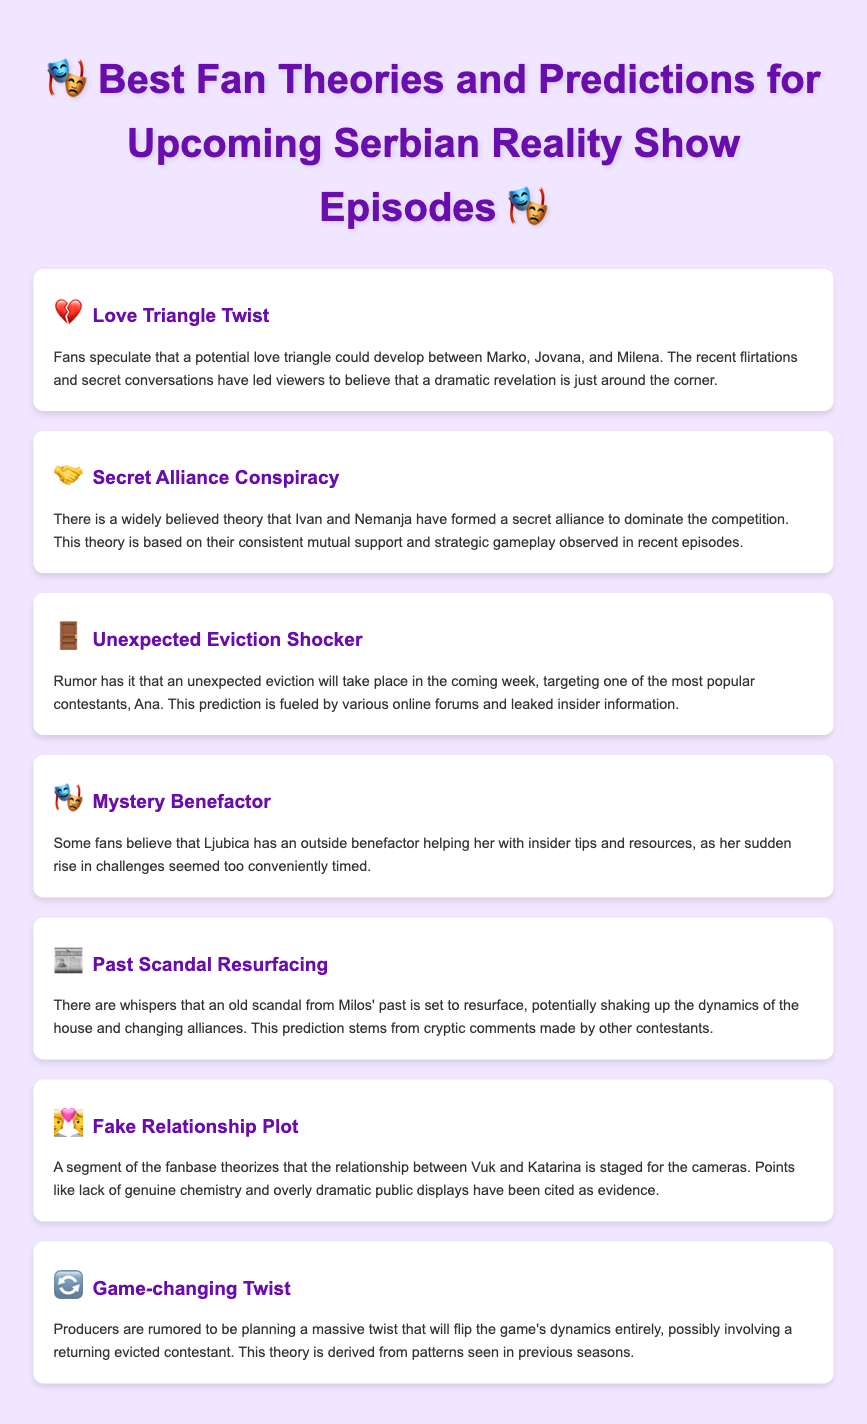What is the first fan theory listed? The first fan theory listed is the one about a love triangle involving Marko, Jovana, and Milena.
Answer: Love Triangle Twist Who are the contestants involved in the secret alliance theory? The contestants involved are Ivan and Nemanja, who are theorized to have formed a secret alliance.
Answer: Ivan and Nemanja What potential event is rumored to happen next week? The document suggests that an unexpected eviction is rumored to take place.
Answer: Unexpected eviction Which contestant is targeted for the rumored eviction? According to the prediction, Ana is the contestant targeted for eviction.
Answer: Ana What is the main speculation about Ljubica? Fans speculate that Ljubica has an outside benefactor helping her with insider tips.
Answer: Mystery Benefactor What type of plot is theorized about Vuk and Katarina? The theory suggests that Vuk and Katarina's relationship may be staged for the cameras.
Answer: Fake Relationship Plot What is the nature of the upcoming twist anticipated by fans? Fans anticipate a game-changing twist that could involve a returning evicted contestant.
Answer: Game-changing Twist What do fans think is going to resurface from Milos' past? Fans believe that an old scandal involving Milos is going to resurface.
Answer: Past Scandal Resurfacing 